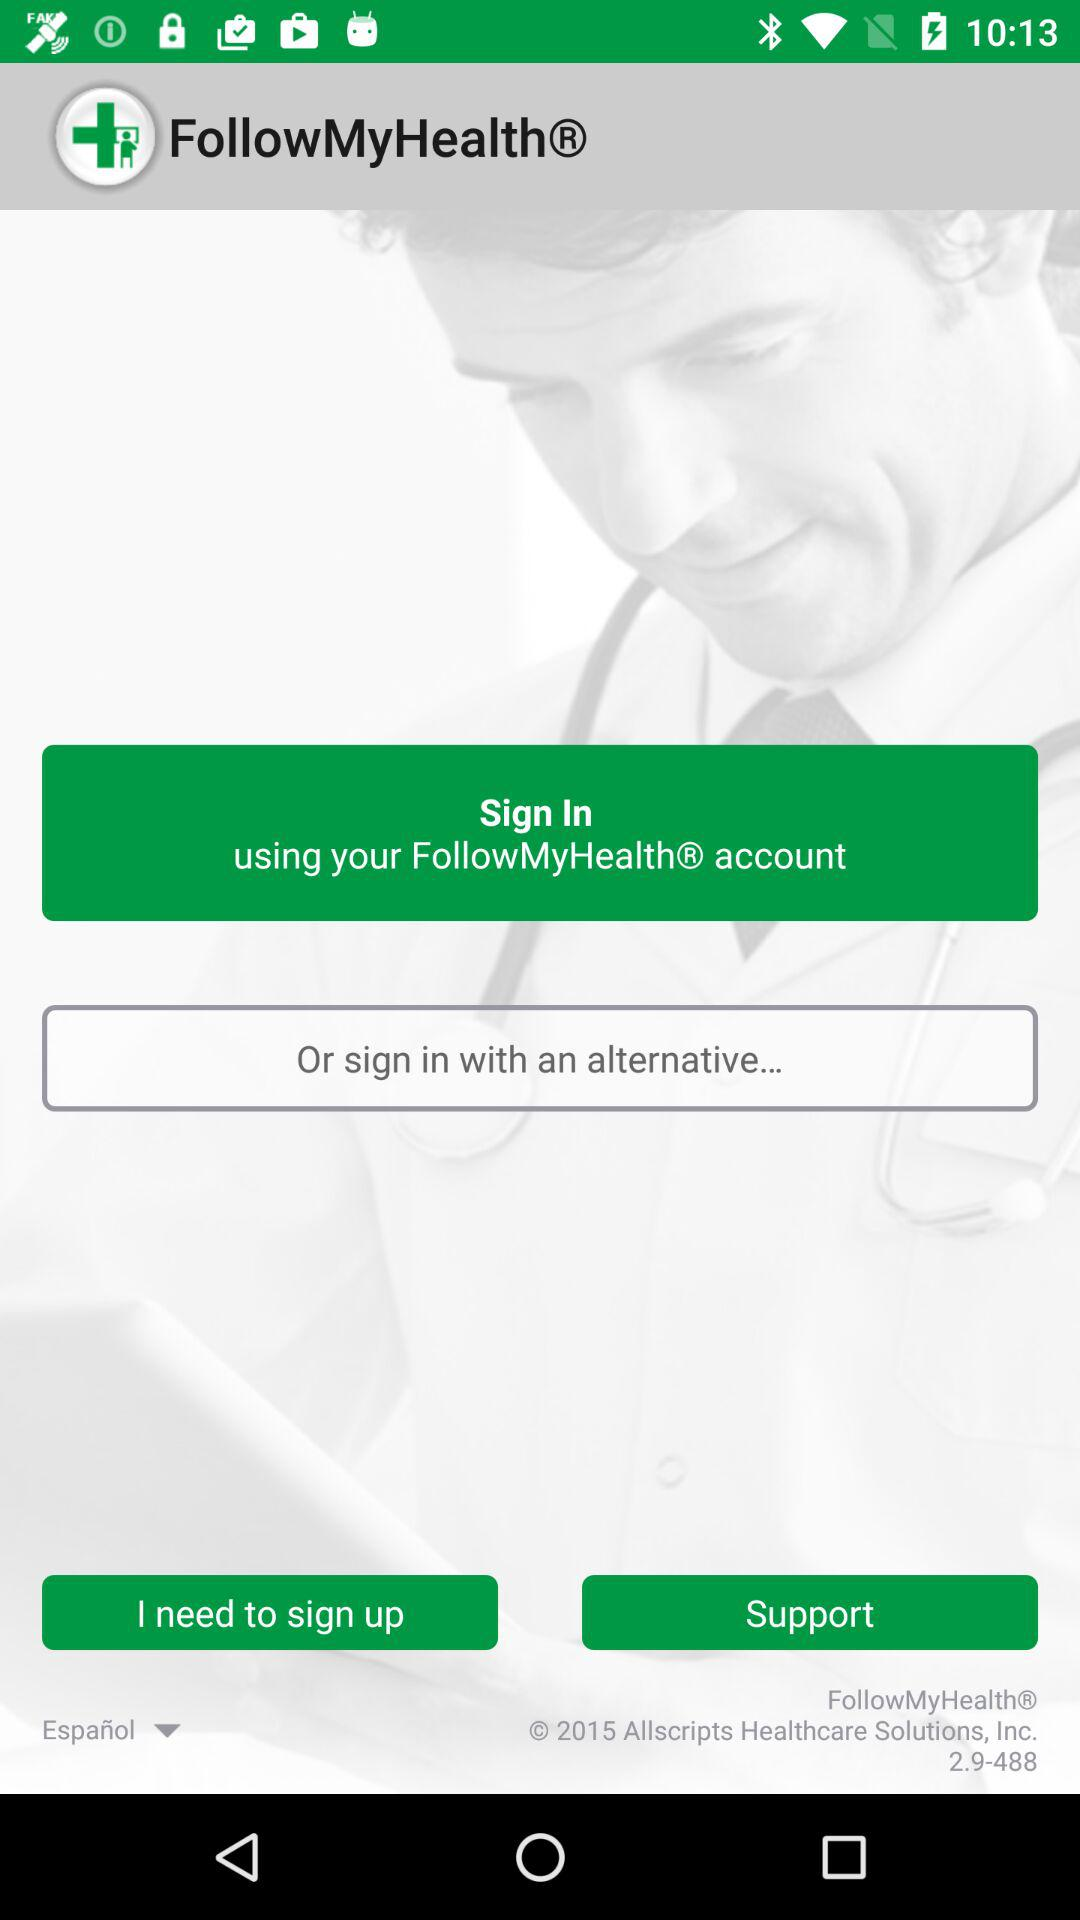Which is the selected language? The selected language is Español. 